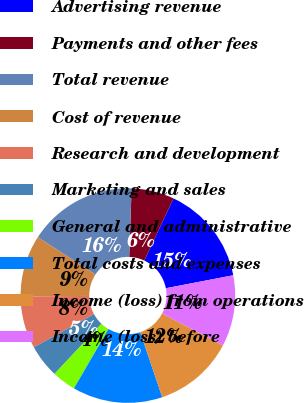Convert chart to OTSL. <chart><loc_0><loc_0><loc_500><loc_500><pie_chart><fcel>Advertising revenue<fcel>Payments and other fees<fcel>Total revenue<fcel>Cost of revenue<fcel>Research and development<fcel>Marketing and sales<fcel>General and administrative<fcel>Total costs and expenses<fcel>Income (loss) from operations<fcel>Income (loss) before<nl><fcel>14.98%<fcel>6.44%<fcel>16.4%<fcel>9.29%<fcel>7.87%<fcel>5.02%<fcel>3.6%<fcel>13.56%<fcel>12.13%<fcel>10.71%<nl></chart> 